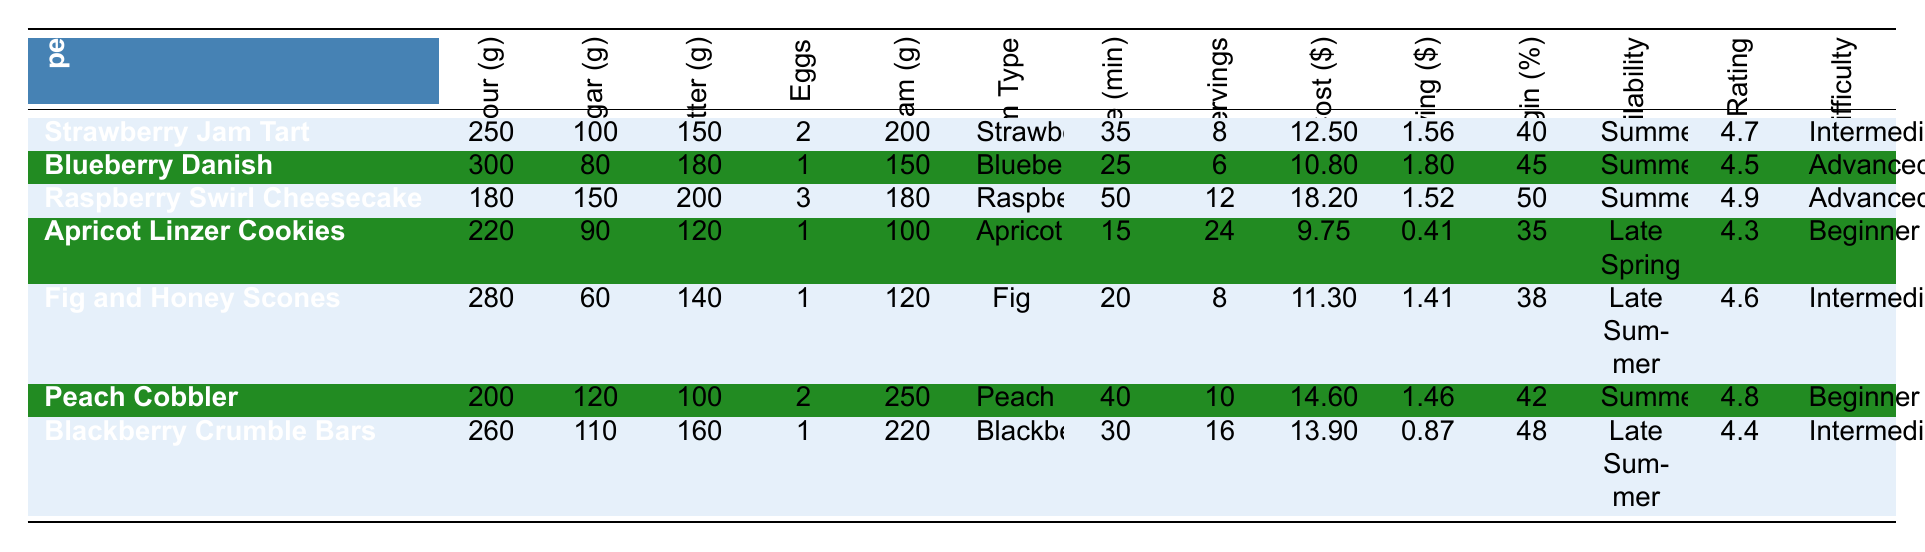What is the baking time for the Raspberry Swirl Cheesecake? The table lists the baking time for each recipe, and for the Raspberry Swirl Cheesecake, it specifically states 50 minutes.
Answer: 50 minutes Which recipe has the highest customer rating? By comparing the Customer Rating column, the Raspberry Swirl Cheesecake has the highest rating at 4.9.
Answer: Raspberry Swirl Cheesecake How many grams of flour are used in the Fig and Honey Scones? In the table, the amount of flour for the Fig and Honey Scones is listed as 280 grams.
Answer: 280 grams What is the total cost of making the Apricot Linzer Cookies? The Total Cost for the Apricot Linzer Cookies is detailed in the table as $9.75.
Answer: $9.75 What is the profit margin percentage for the Blueberry Danish? The column detailing Profit Margin Percentage shows that the Blueberry Danish has a profit margin of 45%.
Answer: 45% Which recipe requires the most homemade jam? Looking at the Homemade Jam grams column, Peach Cobbler requires 250 grams, which is the highest.
Answer: Peach Cobbler How much more sugar is used in the Raspberry Swirl Cheesecake compared to the Blueberry Danish? For the Raspberry Swirl Cheesecake, the sugar amount is 150 grams, and for the Blueberry Danish, it is 80 grams. The difference is 150 - 80 = 70 grams.
Answer: 70 grams What is the total cost of all recipes combined? To find the total cost, I will add up all the Total Cost values: $12.50 + $10.80 + $18.20 + $9.75 + $11.30 + $14.60 + $13.90 = $91.05.
Answer: $91.05 Is the baking time for BlackBerry Crumble Bars longer than that for Apricot Linzer Cookies? The baking time for Blackberry Crumble Bars is 30 minutes, while for Apricot Linzer Cookies, it is 15 minutes. Since 30 minutes is more than 15 minutes, the statement is true.
Answer: Yes What is the average cost per serving for all recipes? To find the average cost per serving, I will sum all the Cost per Serving values ($1.56 + $1.80 + $1.52 + $0.41 + $1.41 + $1.46 + $0.87 = $9.03) and divide by the number of recipes (7): $9.03 / 7 ≈ $1.29.
Answer: $1.29 Which recipe has the lowest preparation difficulty and what is its customer rating? The recipe with the lowest preparation difficulty is Apricot Linzer Cookies, which is rated at 4.3.
Answer: Apricot Linzer Cookies, 4.3 